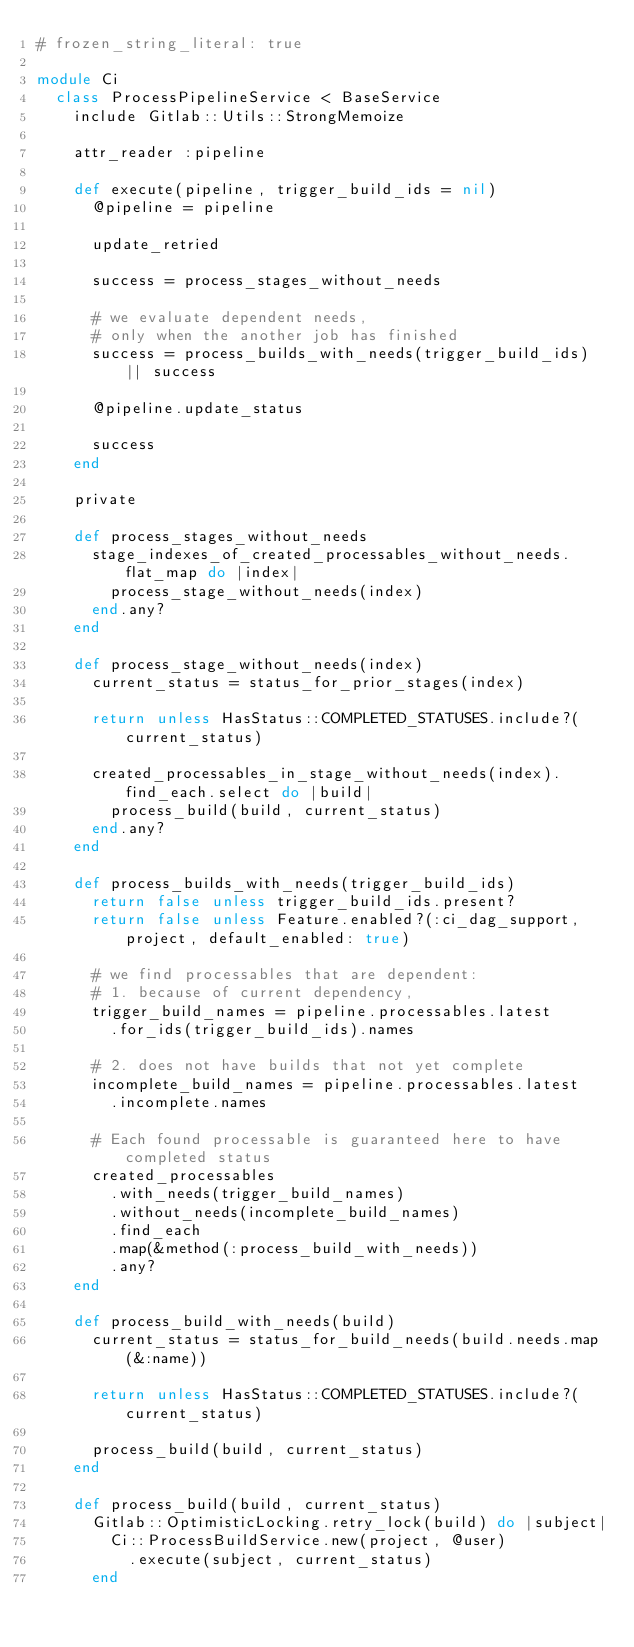<code> <loc_0><loc_0><loc_500><loc_500><_Ruby_># frozen_string_literal: true

module Ci
  class ProcessPipelineService < BaseService
    include Gitlab::Utils::StrongMemoize

    attr_reader :pipeline

    def execute(pipeline, trigger_build_ids = nil)
      @pipeline = pipeline

      update_retried

      success = process_stages_without_needs

      # we evaluate dependent needs,
      # only when the another job has finished
      success = process_builds_with_needs(trigger_build_ids) || success

      @pipeline.update_status

      success
    end

    private

    def process_stages_without_needs
      stage_indexes_of_created_processables_without_needs.flat_map do |index|
        process_stage_without_needs(index)
      end.any?
    end

    def process_stage_without_needs(index)
      current_status = status_for_prior_stages(index)

      return unless HasStatus::COMPLETED_STATUSES.include?(current_status)

      created_processables_in_stage_without_needs(index).find_each.select do |build|
        process_build(build, current_status)
      end.any?
    end

    def process_builds_with_needs(trigger_build_ids)
      return false unless trigger_build_ids.present?
      return false unless Feature.enabled?(:ci_dag_support, project, default_enabled: true)

      # we find processables that are dependent:
      # 1. because of current dependency,
      trigger_build_names = pipeline.processables.latest
        .for_ids(trigger_build_ids).names

      # 2. does not have builds that not yet complete
      incomplete_build_names = pipeline.processables.latest
        .incomplete.names

      # Each found processable is guaranteed here to have completed status
      created_processables
        .with_needs(trigger_build_names)
        .without_needs(incomplete_build_names)
        .find_each
        .map(&method(:process_build_with_needs))
        .any?
    end

    def process_build_with_needs(build)
      current_status = status_for_build_needs(build.needs.map(&:name))

      return unless HasStatus::COMPLETED_STATUSES.include?(current_status)

      process_build(build, current_status)
    end

    def process_build(build, current_status)
      Gitlab::OptimisticLocking.retry_lock(build) do |subject|
        Ci::ProcessBuildService.new(project, @user)
          .execute(subject, current_status)
      end</code> 